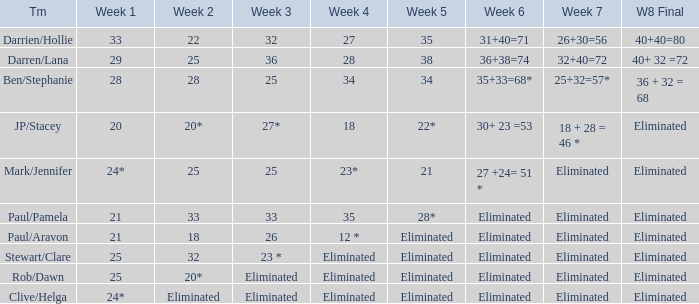Name the week 3 for team of mark/jennifer 25.0. 